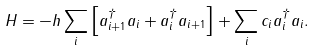Convert formula to latex. <formula><loc_0><loc_0><loc_500><loc_500>H = - h \sum _ { i } \left [ a _ { i + 1 } ^ { \dagger } a _ { i } + a _ { i } ^ { \dagger } a _ { i + 1 } \right ] + \sum _ { i } c _ { i } a _ { i } ^ { \dagger } a _ { i } .</formula> 